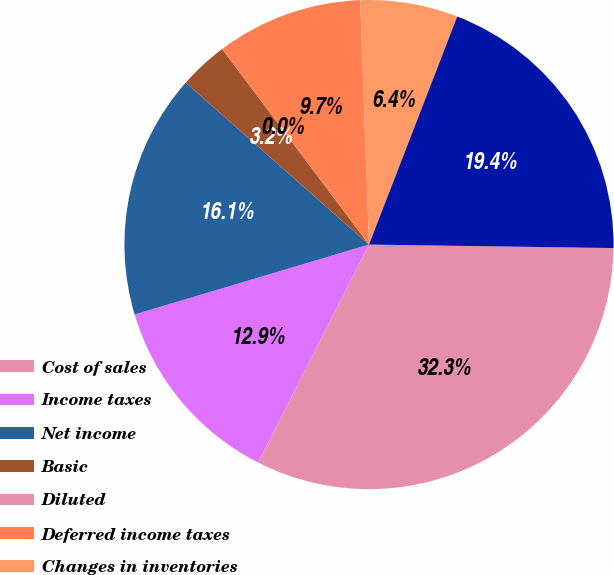<chart> <loc_0><loc_0><loc_500><loc_500><pie_chart><fcel>Cost of sales<fcel>Income taxes<fcel>Net income<fcel>Basic<fcel>Diluted<fcel>Deferred income taxes<fcel>Changes in inventories<fcel>Net cash provided by operating<nl><fcel>32.26%<fcel>12.9%<fcel>16.13%<fcel>3.23%<fcel>0.0%<fcel>9.68%<fcel>6.45%<fcel>19.35%<nl></chart> 